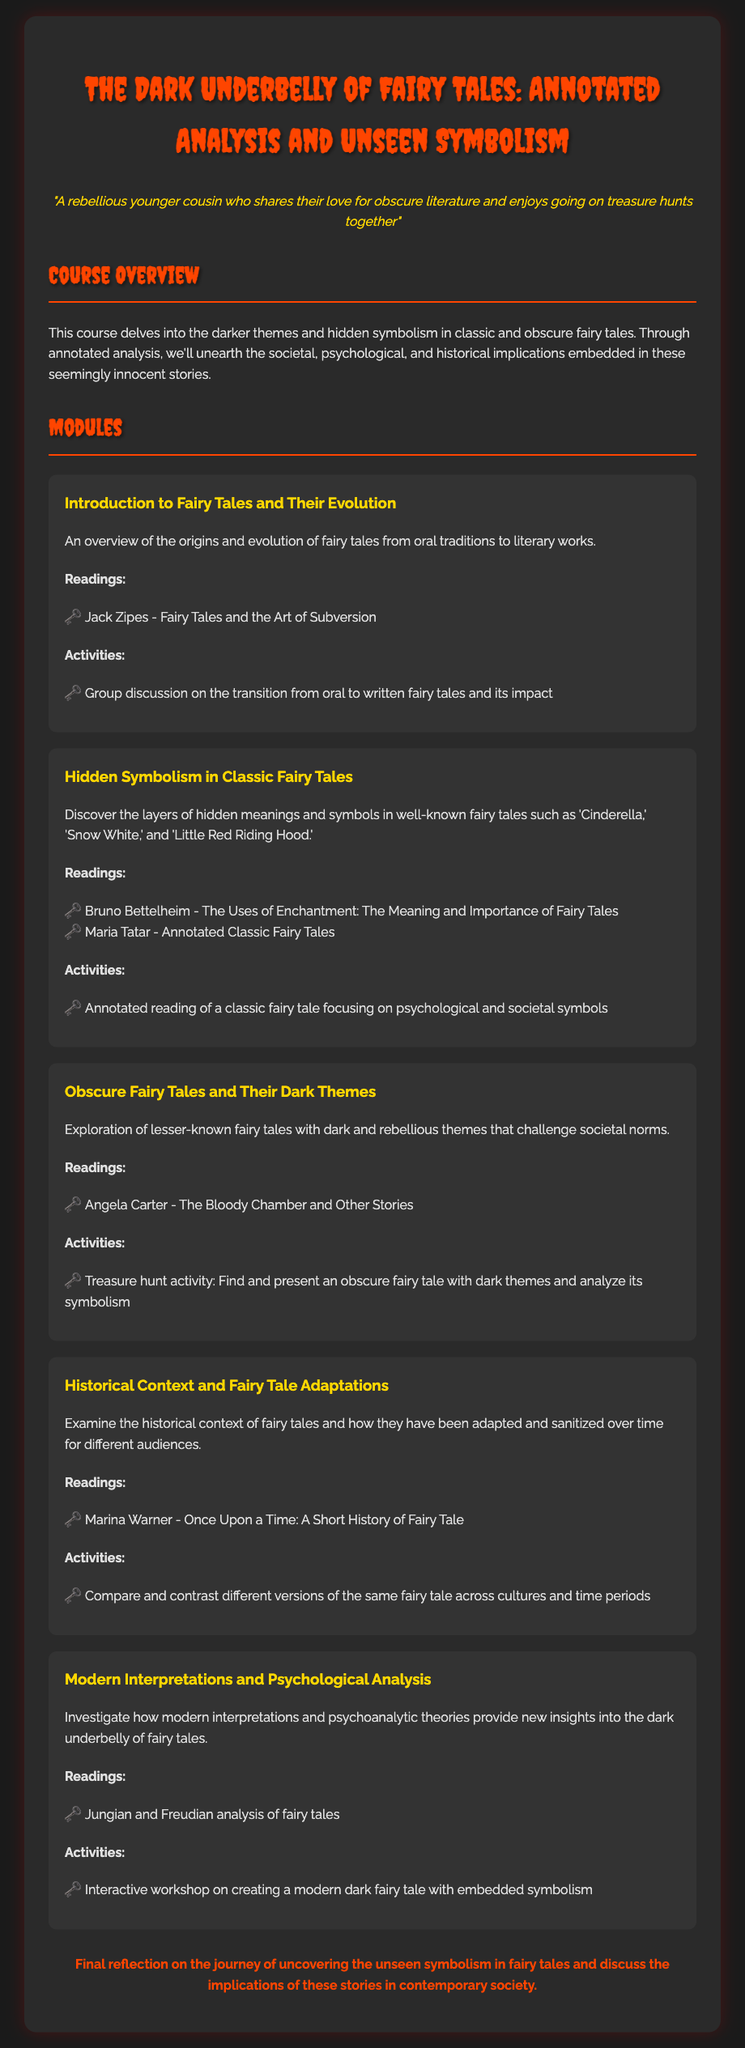What is the title of the course? The title of the course is provided at the beginning of the document.
Answer: The Dark Underbelly of Fairy Tales: Annotated Analysis and Unseen Symbolism Who is the author of "Fairy Tales and the Art of Subversion"? The document lists Jack Zipes as the author of this reading.
Answer: Jack Zipes What is emphasized in the module about obscure fairy tales? The module’s description highlights exploration of dark and rebellious themes.
Answer: Dark and rebellious themes How many modules are included in the syllabus? The number of modules can be counted from the section outlining the modules.
Answer: Five Which author is associated with the reading "The Bloody Chamber and Other Stories"? The document names Angela Carter as the author related to this reading.
Answer: Angela Carter What type of activity is planned for exploring obscure fairy tales? The activity specified is a treasure hunt to find and present an obscure fairy tale.
Answer: Treasure hunt According to the syllabus, what psychological theories are applied to fairy tales? The document mentions Jungian and Freudian analysis for psychological insights.
Answer: Jungian and Freudian What does the final reflection discuss? The conclusion section indicates it reflects on uncovering unseen symbolism and its implications.
Answer: Unseen symbolism and implications 